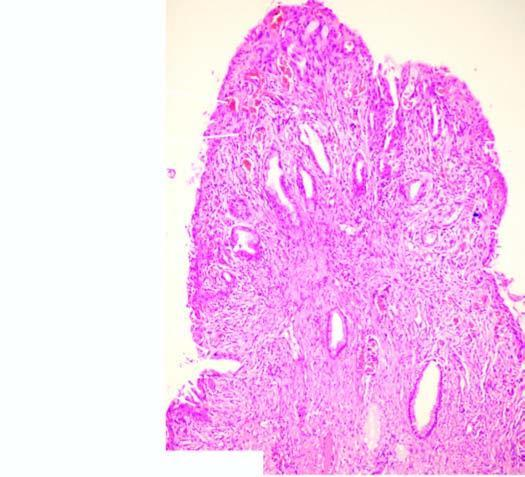what is the surface covered by?
Answer the question using a single word or phrase. Endocervical mucosa with squamous metaplasia 